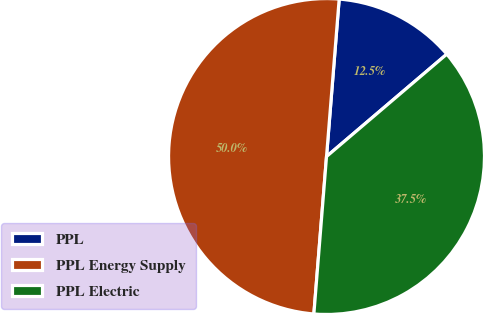Convert chart to OTSL. <chart><loc_0><loc_0><loc_500><loc_500><pie_chart><fcel>PPL<fcel>PPL Energy Supply<fcel>PPL Electric<nl><fcel>12.5%<fcel>50.0%<fcel>37.5%<nl></chart> 